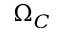<formula> <loc_0><loc_0><loc_500><loc_500>\Omega _ { C }</formula> 